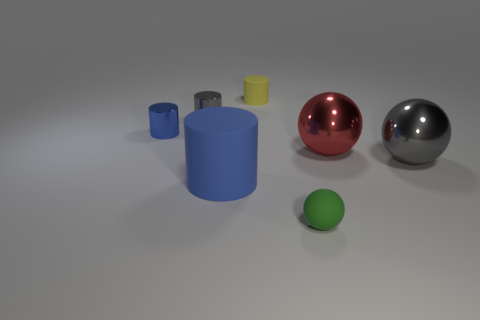Is the number of blue shiny cylinders greater than the number of small green blocks?
Your response must be concise. Yes. There is a gray metal thing right of the large red ball; does it have the same shape as the blue matte object?
Your answer should be compact. No. How many things are to the right of the blue shiny object and behind the big red object?
Provide a succinct answer. 2. How many other small objects are the same shape as the yellow thing?
Keep it short and to the point. 2. There is a small matte object to the left of the small matte object in front of the tiny yellow rubber cylinder; what color is it?
Provide a short and direct response. Yellow. Do the small gray metal object and the large metal thing that is right of the red metallic object have the same shape?
Offer a terse response. No. There is a sphere that is in front of the matte cylinder to the left of the small yellow matte cylinder that is behind the tiny green object; what is its material?
Your answer should be compact. Rubber. Are there any gray matte objects of the same size as the yellow matte cylinder?
Provide a short and direct response. No. What is the size of the yellow object that is made of the same material as the green thing?
Provide a short and direct response. Small. The blue matte object is what shape?
Your answer should be compact. Cylinder. 